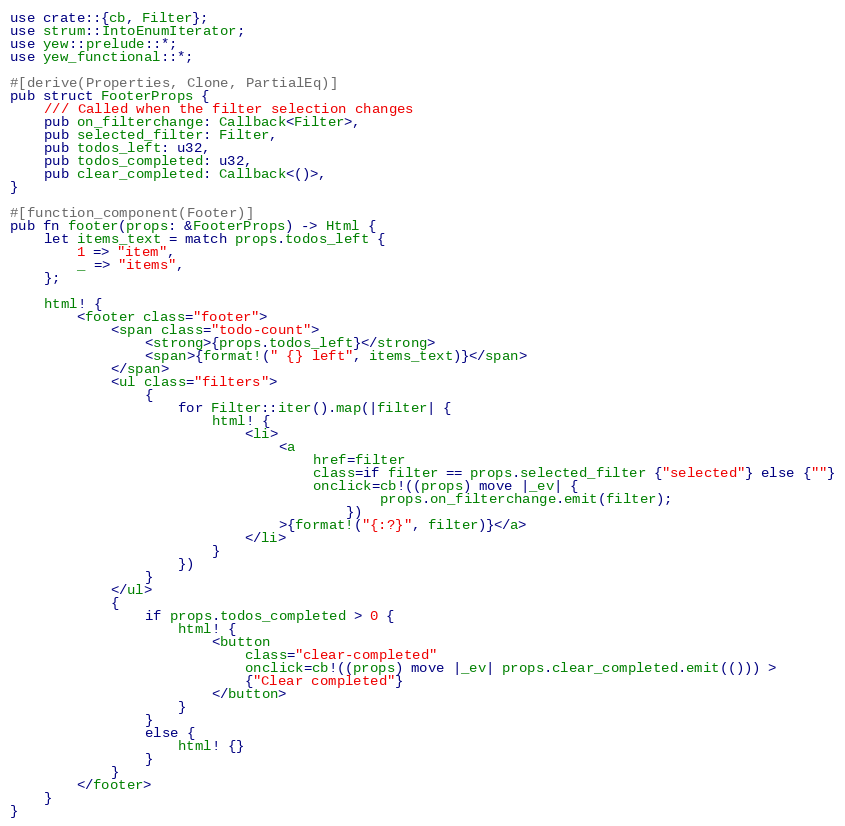Convert code to text. <code><loc_0><loc_0><loc_500><loc_500><_Rust_>use crate::{cb, Filter};
use strum::IntoEnumIterator;
use yew::prelude::*;
use yew_functional::*;

#[derive(Properties, Clone, PartialEq)]
pub struct FooterProps {
    /// Called when the filter selection changes
    pub on_filterchange: Callback<Filter>,
    pub selected_filter: Filter,
    pub todos_left: u32,
    pub todos_completed: u32,
    pub clear_completed: Callback<()>,
}

#[function_component(Footer)]
pub fn footer(props: &FooterProps) -> Html {
    let items_text = match props.todos_left {
        1 => "item",
        _ => "items",
    };

    html! {
        <footer class="footer">
            <span class="todo-count">
                <strong>{props.todos_left}</strong>
                <span>{format!(" {} left", items_text)}</span>
            </span>
            <ul class="filters">
                {
                    for Filter::iter().map(|filter| {
                        html! {
                            <li>
                                <a
                                    href=filter
                                    class=if filter == props.selected_filter {"selected"} else {""}
                                    onclick=cb!((props) move |_ev| {
                                            props.on_filterchange.emit(filter);
                                        })
                                >{format!("{:?}", filter)}</a>
                            </li>
                        }
                    })
                }
            </ul>
            {
                if props.todos_completed > 0 {
                    html! {
                        <button
                            class="clear-completed"
                            onclick=cb!((props) move |_ev| props.clear_completed.emit(())) >
                            {"Clear completed"}
                        </button>
                    }
                }
                else {
                    html! {}
                }
            }
        </footer>
    }
}
</code> 